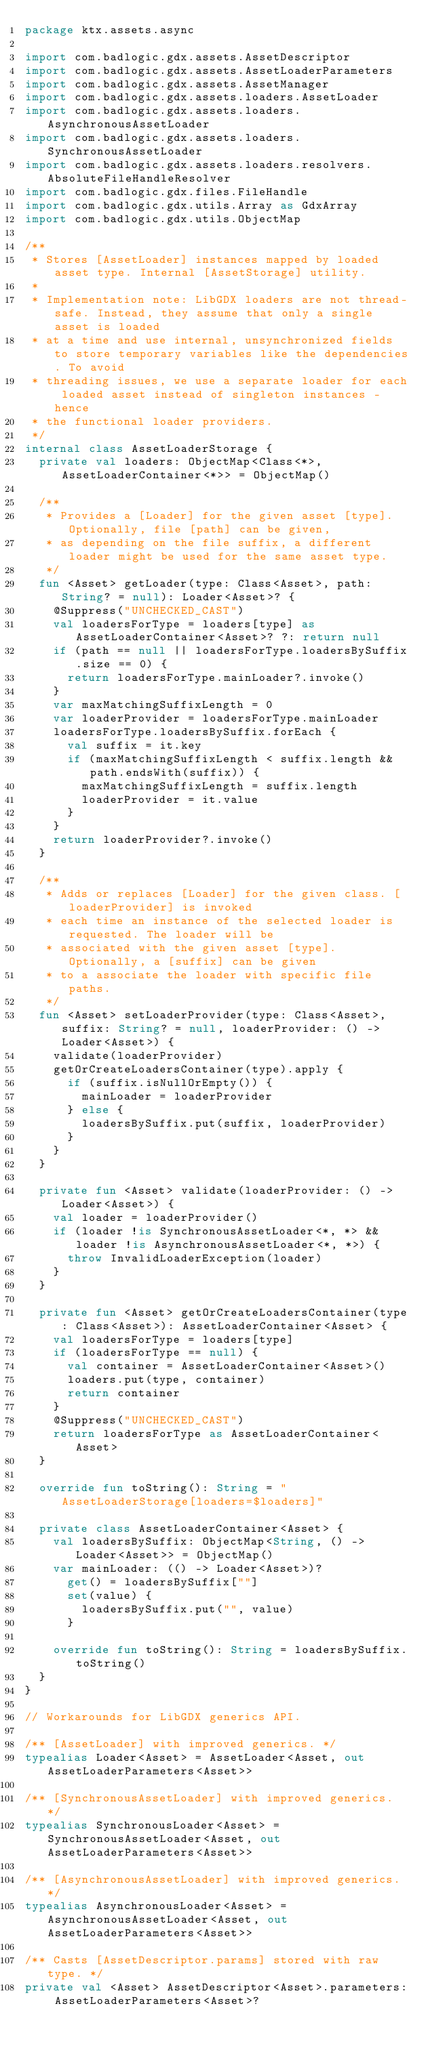Convert code to text. <code><loc_0><loc_0><loc_500><loc_500><_Kotlin_>package ktx.assets.async

import com.badlogic.gdx.assets.AssetDescriptor
import com.badlogic.gdx.assets.AssetLoaderParameters
import com.badlogic.gdx.assets.AssetManager
import com.badlogic.gdx.assets.loaders.AssetLoader
import com.badlogic.gdx.assets.loaders.AsynchronousAssetLoader
import com.badlogic.gdx.assets.loaders.SynchronousAssetLoader
import com.badlogic.gdx.assets.loaders.resolvers.AbsoluteFileHandleResolver
import com.badlogic.gdx.files.FileHandle
import com.badlogic.gdx.utils.Array as GdxArray
import com.badlogic.gdx.utils.ObjectMap

/**
 * Stores [AssetLoader] instances mapped by loaded asset type. Internal [AssetStorage] utility.
 *
 * Implementation note: LibGDX loaders are not thread-safe. Instead, they assume that only a single asset is loaded
 * at a time and use internal, unsynchronized fields to store temporary variables like the dependencies. To avoid
 * threading issues, we use a separate loader for each loaded asset instead of singleton instances - hence
 * the functional loader providers.
 */
internal class AssetLoaderStorage {
  private val loaders: ObjectMap<Class<*>, AssetLoaderContainer<*>> = ObjectMap()

  /**
   * Provides a [Loader] for the given asset [type]. Optionally, file [path] can be given,
   * as depending on the file suffix, a different loader might be used for the same asset type.
   */
  fun <Asset> getLoader(type: Class<Asset>, path: String? = null): Loader<Asset>? {
    @Suppress("UNCHECKED_CAST")
    val loadersForType = loaders[type] as AssetLoaderContainer<Asset>? ?: return null
    if (path == null || loadersForType.loadersBySuffix.size == 0) {
      return loadersForType.mainLoader?.invoke()
    }
    var maxMatchingSuffixLength = 0
    var loaderProvider = loadersForType.mainLoader
    loadersForType.loadersBySuffix.forEach {
      val suffix = it.key
      if (maxMatchingSuffixLength < suffix.length && path.endsWith(suffix)) {
        maxMatchingSuffixLength = suffix.length
        loaderProvider = it.value
      }
    }
    return loaderProvider?.invoke()
  }

  /**
   * Adds or replaces [Loader] for the given class. [loaderProvider] is invoked
   * each time an instance of the selected loader is requested. The loader will be
   * associated with the given asset [type]. Optionally, a [suffix] can be given
   * to a associate the loader with specific file paths.
   */
  fun <Asset> setLoaderProvider(type: Class<Asset>, suffix: String? = null, loaderProvider: () -> Loader<Asset>) {
    validate(loaderProvider)
    getOrCreateLoadersContainer(type).apply {
      if (suffix.isNullOrEmpty()) {
        mainLoader = loaderProvider
      } else {
        loadersBySuffix.put(suffix, loaderProvider)
      }
    }
  }

  private fun <Asset> validate(loaderProvider: () -> Loader<Asset>) {
    val loader = loaderProvider()
    if (loader !is SynchronousAssetLoader<*, *> && loader !is AsynchronousAssetLoader<*, *>) {
      throw InvalidLoaderException(loader)
    }
  }

  private fun <Asset> getOrCreateLoadersContainer(type: Class<Asset>): AssetLoaderContainer<Asset> {
    val loadersForType = loaders[type]
    if (loadersForType == null) {
      val container = AssetLoaderContainer<Asset>()
      loaders.put(type, container)
      return container
    }
    @Suppress("UNCHECKED_CAST")
    return loadersForType as AssetLoaderContainer<Asset>
  }

  override fun toString(): String = "AssetLoaderStorage[loaders=$loaders]"

  private class AssetLoaderContainer<Asset> {
    val loadersBySuffix: ObjectMap<String, () -> Loader<Asset>> = ObjectMap()
    var mainLoader: (() -> Loader<Asset>)?
      get() = loadersBySuffix[""]
      set(value) {
        loadersBySuffix.put("", value)
      }

    override fun toString(): String = loadersBySuffix.toString()
  }
}

// Workarounds for LibGDX generics API.

/** [AssetLoader] with improved generics. */
typealias Loader<Asset> = AssetLoader<Asset, out AssetLoaderParameters<Asset>>

/** [SynchronousAssetLoader] with improved generics. */
typealias SynchronousLoader<Asset> = SynchronousAssetLoader<Asset, out AssetLoaderParameters<Asset>>

/** [AsynchronousAssetLoader] with improved generics. */
typealias AsynchronousLoader<Asset> = AsynchronousAssetLoader<Asset, out AssetLoaderParameters<Asset>>

/** Casts [AssetDescriptor.params] stored with raw type. */
private val <Asset> AssetDescriptor<Asset>.parameters: AssetLoaderParameters<Asset>?</code> 